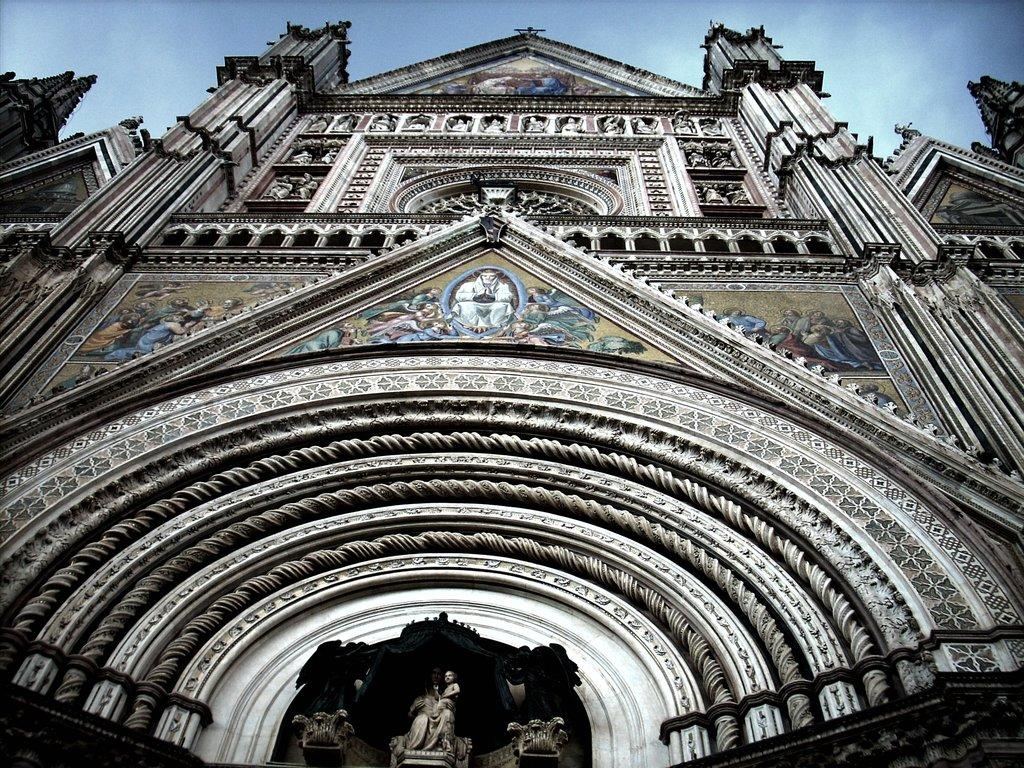What type of structure is present in the image? There is a building in the image. What artistic elements can be seen in the image? There are statues, paintings on the wall, and carvings in the image. What can be seen in the background of the image? There is a sky visible in the background of the image. What type of knife is being used to cut the paintings in the image? There is no knife present in the image, nor are any paintings being cut. 